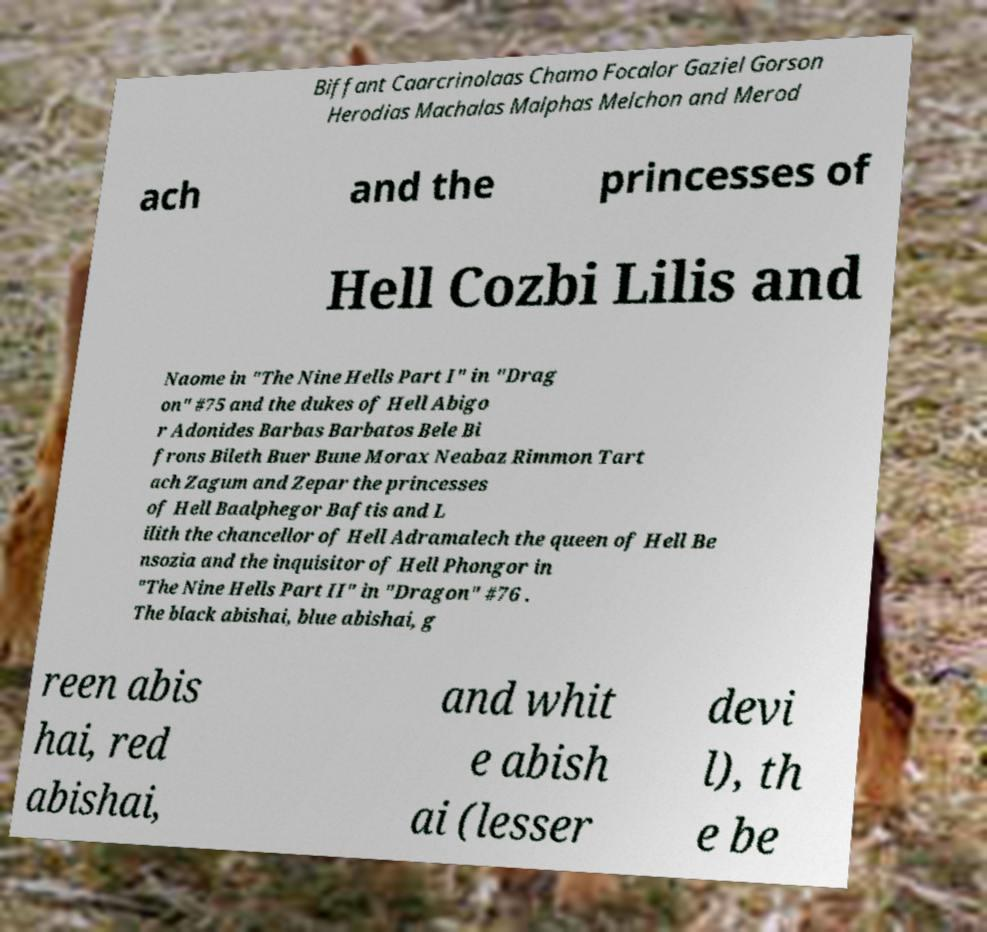What messages or text are displayed in this image? I need them in a readable, typed format. Biffant Caarcrinolaas Chamo Focalor Gaziel Gorson Herodias Machalas Malphas Melchon and Merod ach and the princesses of Hell Cozbi Lilis and Naome in "The Nine Hells Part I" in "Drag on" #75 and the dukes of Hell Abigo r Adonides Barbas Barbatos Bele Bi frons Bileth Buer Bune Morax Neabaz Rimmon Tart ach Zagum and Zepar the princesses of Hell Baalphegor Baftis and L ilith the chancellor of Hell Adramalech the queen of Hell Be nsozia and the inquisitor of Hell Phongor in "The Nine Hells Part II" in "Dragon" #76 . The black abishai, blue abishai, g reen abis hai, red abishai, and whit e abish ai (lesser devi l), th e be 